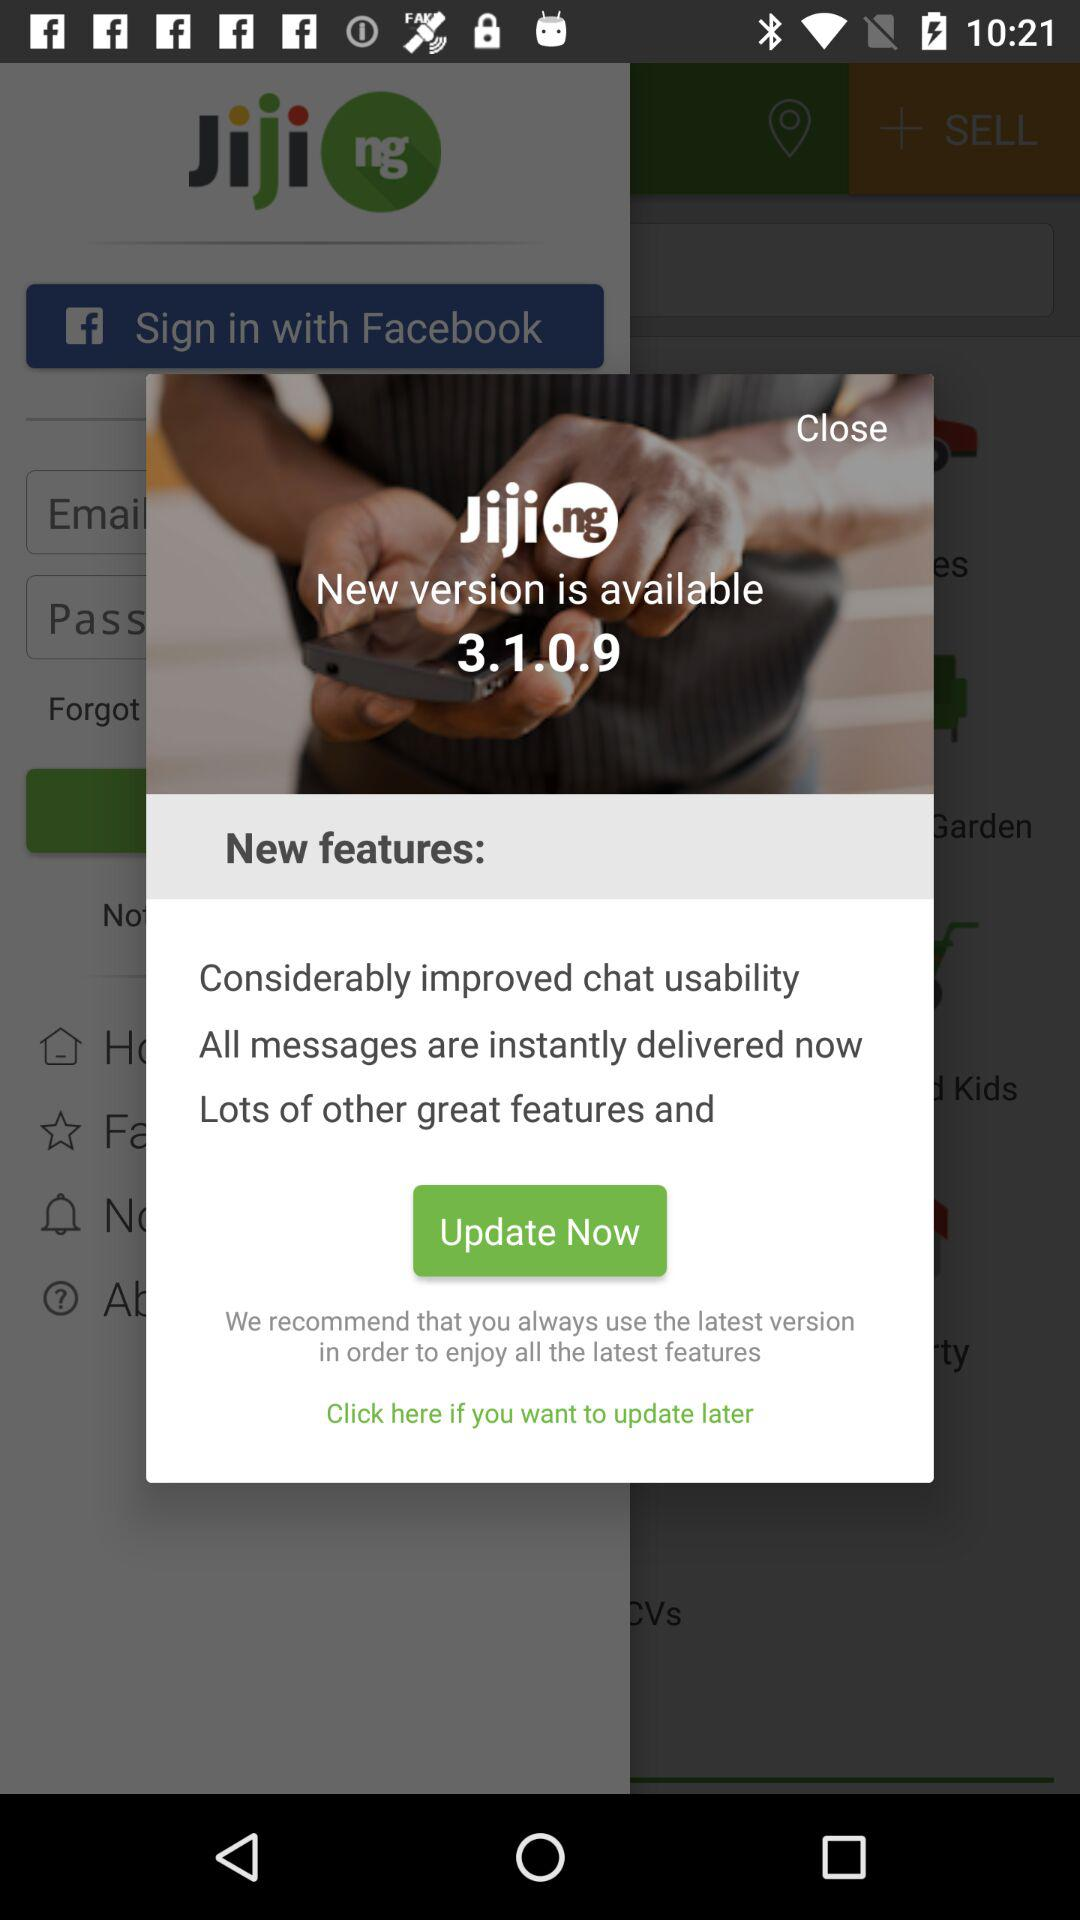What is the new version? The new version is 3.1.0.9. 